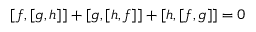Convert formula to latex. <formula><loc_0><loc_0><loc_500><loc_500>[ f , [ g , h ] ] + [ g , [ h , f ] ] + [ h , [ f , g ] ] = 0</formula> 